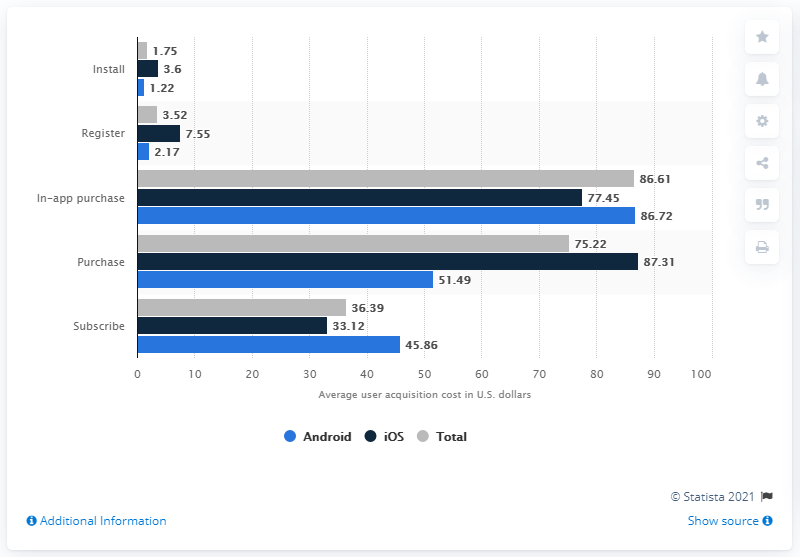Highlight a few significant elements in this photo. The average acquisition cost for iOS was 86.72 dollars. The cost of an in-app purchase for Android was approximately 77.45. 